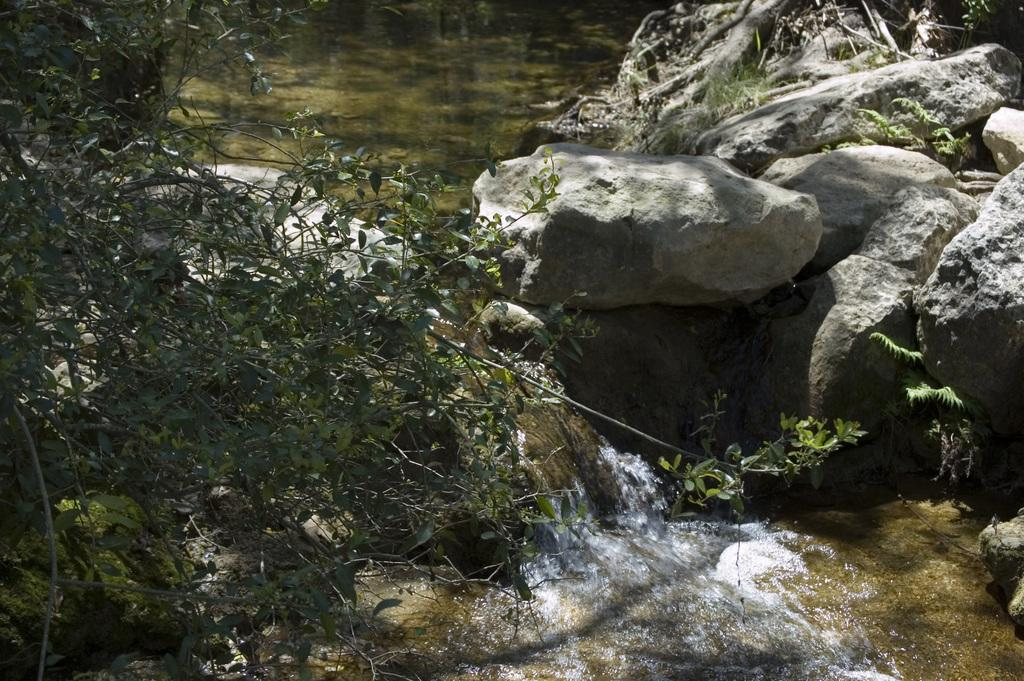What type of vegetation is on the left side of the image? There is a plant on the left side of the image. What natural feature can be seen in the image? There is a small waterfall in the image. What type of geological formation is on the right side of the image? There are rocks on the right side of the image. What type of dress is hanging on the rocks in the image? There is no dress present in the image; it features a plant, a small waterfall, and rocks. Can you tell me how many hoses are connected to the waterfall in the image? There are no hoses present in the image; it features a plant, a small waterfall, and rocks. 